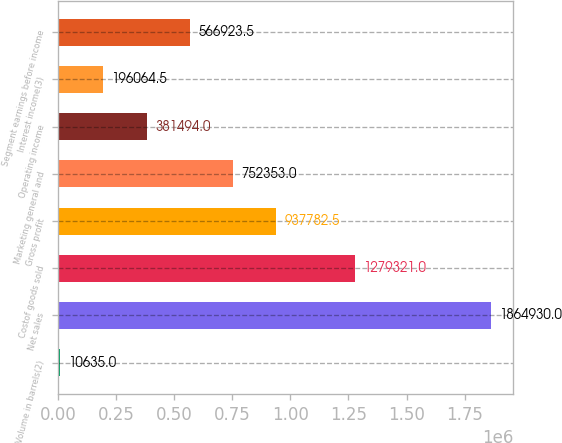<chart> <loc_0><loc_0><loc_500><loc_500><bar_chart><fcel>Volume in barrels(2)<fcel>Net sales<fcel>Costof goods sold<fcel>Gross profit<fcel>Marketing general and<fcel>Operating income<fcel>Interest income(3)<fcel>Segment earnings before income<nl><fcel>10635<fcel>1.86493e+06<fcel>1.27932e+06<fcel>937782<fcel>752353<fcel>381494<fcel>196064<fcel>566924<nl></chart> 